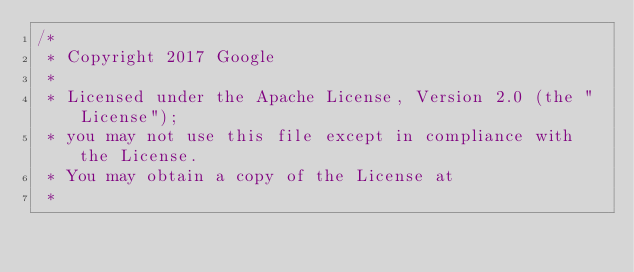Convert code to text. <code><loc_0><loc_0><loc_500><loc_500><_ObjectiveC_>/*
 * Copyright 2017 Google
 *
 * Licensed under the Apache License, Version 2.0 (the "License");
 * you may not use this file except in compliance with the License.
 * You may obtain a copy of the License at
 *</code> 